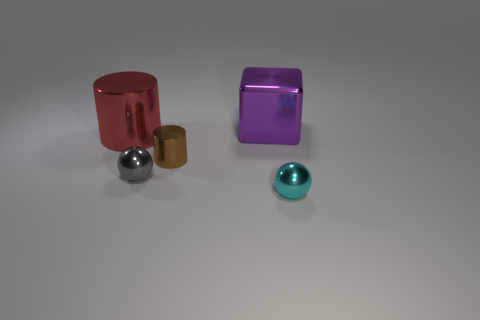Add 5 shiny blocks. How many objects exist? 10 Subtract all balls. How many objects are left? 3 Subtract all yellow blocks. How many blue cylinders are left? 0 Subtract all cyan matte cubes. Subtract all blocks. How many objects are left? 4 Add 5 big metal objects. How many big metal objects are left? 7 Add 3 metal cubes. How many metal cubes exist? 4 Subtract all red cylinders. How many cylinders are left? 1 Subtract 0 blue cubes. How many objects are left? 5 Subtract 2 spheres. How many spheres are left? 0 Subtract all red balls. Subtract all purple cylinders. How many balls are left? 2 